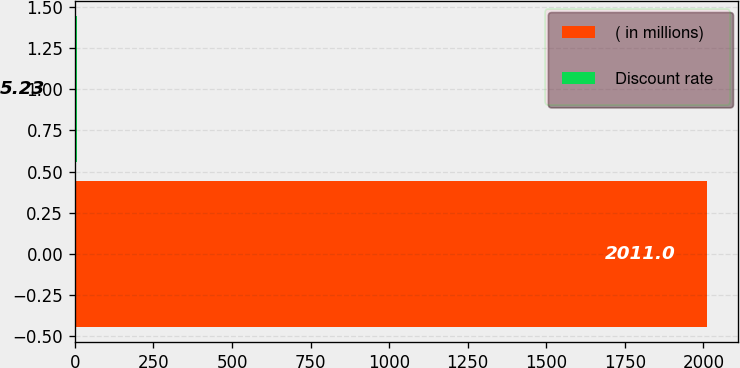Convert chart to OTSL. <chart><loc_0><loc_0><loc_500><loc_500><bar_chart><fcel>( in millions)<fcel>Discount rate<nl><fcel>2011<fcel>5.23<nl></chart> 